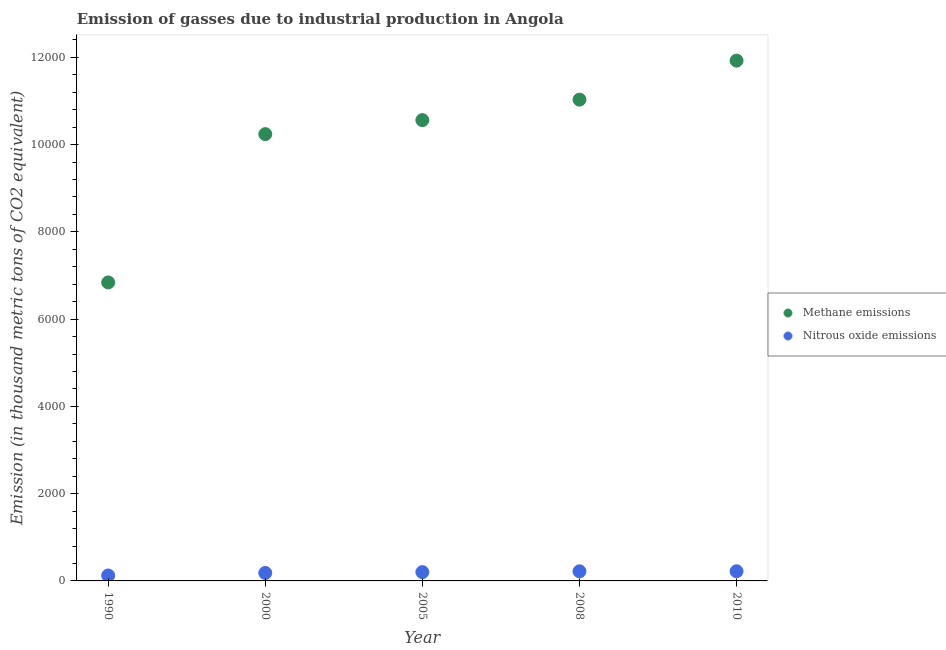How many different coloured dotlines are there?
Provide a succinct answer. 2. What is the amount of methane emissions in 1990?
Provide a succinct answer. 6841.7. Across all years, what is the maximum amount of methane emissions?
Offer a very short reply. 1.19e+04. Across all years, what is the minimum amount of nitrous oxide emissions?
Ensure brevity in your answer.  124.8. What is the total amount of methane emissions in the graph?
Provide a short and direct response. 5.06e+04. What is the difference between the amount of methane emissions in 1990 and that in 2008?
Your response must be concise. -4190.2. What is the difference between the amount of methane emissions in 2000 and the amount of nitrous oxide emissions in 2005?
Give a very brief answer. 1.00e+04. What is the average amount of methane emissions per year?
Provide a succinct answer. 1.01e+04. In the year 2010, what is the difference between the amount of methane emissions and amount of nitrous oxide emissions?
Your answer should be very brief. 1.17e+04. What is the ratio of the amount of nitrous oxide emissions in 2005 to that in 2010?
Make the answer very short. 0.91. What is the difference between the highest and the lowest amount of nitrous oxide emissions?
Provide a succinct answer. 96.6. In how many years, is the amount of nitrous oxide emissions greater than the average amount of nitrous oxide emissions taken over all years?
Your answer should be very brief. 3. Does the amount of nitrous oxide emissions monotonically increase over the years?
Give a very brief answer. Yes. Is the amount of nitrous oxide emissions strictly greater than the amount of methane emissions over the years?
Give a very brief answer. No. Is the amount of methane emissions strictly less than the amount of nitrous oxide emissions over the years?
Provide a short and direct response. No. How many dotlines are there?
Offer a very short reply. 2. How many years are there in the graph?
Your answer should be compact. 5. What is the difference between two consecutive major ticks on the Y-axis?
Your answer should be compact. 2000. Where does the legend appear in the graph?
Give a very brief answer. Center right. How are the legend labels stacked?
Your response must be concise. Vertical. What is the title of the graph?
Your answer should be compact. Emission of gasses due to industrial production in Angola. Does "Fertility rate" appear as one of the legend labels in the graph?
Offer a terse response. No. What is the label or title of the X-axis?
Keep it short and to the point. Year. What is the label or title of the Y-axis?
Ensure brevity in your answer.  Emission (in thousand metric tons of CO2 equivalent). What is the Emission (in thousand metric tons of CO2 equivalent) of Methane emissions in 1990?
Your answer should be compact. 6841.7. What is the Emission (in thousand metric tons of CO2 equivalent) in Nitrous oxide emissions in 1990?
Give a very brief answer. 124.8. What is the Emission (in thousand metric tons of CO2 equivalent) of Methane emissions in 2000?
Offer a very short reply. 1.02e+04. What is the Emission (in thousand metric tons of CO2 equivalent) in Nitrous oxide emissions in 2000?
Provide a succinct answer. 182.5. What is the Emission (in thousand metric tons of CO2 equivalent) in Methane emissions in 2005?
Offer a very short reply. 1.06e+04. What is the Emission (in thousand metric tons of CO2 equivalent) in Nitrous oxide emissions in 2005?
Your answer should be compact. 201.8. What is the Emission (in thousand metric tons of CO2 equivalent) of Methane emissions in 2008?
Provide a succinct answer. 1.10e+04. What is the Emission (in thousand metric tons of CO2 equivalent) of Nitrous oxide emissions in 2008?
Offer a terse response. 220.4. What is the Emission (in thousand metric tons of CO2 equivalent) of Methane emissions in 2010?
Provide a succinct answer. 1.19e+04. What is the Emission (in thousand metric tons of CO2 equivalent) of Nitrous oxide emissions in 2010?
Make the answer very short. 221.4. Across all years, what is the maximum Emission (in thousand metric tons of CO2 equivalent) of Methane emissions?
Provide a short and direct response. 1.19e+04. Across all years, what is the maximum Emission (in thousand metric tons of CO2 equivalent) of Nitrous oxide emissions?
Offer a very short reply. 221.4. Across all years, what is the minimum Emission (in thousand metric tons of CO2 equivalent) of Methane emissions?
Offer a very short reply. 6841.7. Across all years, what is the minimum Emission (in thousand metric tons of CO2 equivalent) in Nitrous oxide emissions?
Make the answer very short. 124.8. What is the total Emission (in thousand metric tons of CO2 equivalent) in Methane emissions in the graph?
Offer a very short reply. 5.06e+04. What is the total Emission (in thousand metric tons of CO2 equivalent) in Nitrous oxide emissions in the graph?
Give a very brief answer. 950.9. What is the difference between the Emission (in thousand metric tons of CO2 equivalent) in Methane emissions in 1990 and that in 2000?
Provide a short and direct response. -3399.1. What is the difference between the Emission (in thousand metric tons of CO2 equivalent) of Nitrous oxide emissions in 1990 and that in 2000?
Your answer should be compact. -57.7. What is the difference between the Emission (in thousand metric tons of CO2 equivalent) in Methane emissions in 1990 and that in 2005?
Make the answer very short. -3720.7. What is the difference between the Emission (in thousand metric tons of CO2 equivalent) in Nitrous oxide emissions in 1990 and that in 2005?
Provide a short and direct response. -77. What is the difference between the Emission (in thousand metric tons of CO2 equivalent) in Methane emissions in 1990 and that in 2008?
Give a very brief answer. -4190.2. What is the difference between the Emission (in thousand metric tons of CO2 equivalent) of Nitrous oxide emissions in 1990 and that in 2008?
Make the answer very short. -95.6. What is the difference between the Emission (in thousand metric tons of CO2 equivalent) of Methane emissions in 1990 and that in 2010?
Offer a terse response. -5084.3. What is the difference between the Emission (in thousand metric tons of CO2 equivalent) in Nitrous oxide emissions in 1990 and that in 2010?
Provide a succinct answer. -96.6. What is the difference between the Emission (in thousand metric tons of CO2 equivalent) of Methane emissions in 2000 and that in 2005?
Ensure brevity in your answer.  -321.6. What is the difference between the Emission (in thousand metric tons of CO2 equivalent) in Nitrous oxide emissions in 2000 and that in 2005?
Ensure brevity in your answer.  -19.3. What is the difference between the Emission (in thousand metric tons of CO2 equivalent) in Methane emissions in 2000 and that in 2008?
Your answer should be compact. -791.1. What is the difference between the Emission (in thousand metric tons of CO2 equivalent) of Nitrous oxide emissions in 2000 and that in 2008?
Offer a very short reply. -37.9. What is the difference between the Emission (in thousand metric tons of CO2 equivalent) in Methane emissions in 2000 and that in 2010?
Ensure brevity in your answer.  -1685.2. What is the difference between the Emission (in thousand metric tons of CO2 equivalent) in Nitrous oxide emissions in 2000 and that in 2010?
Your answer should be very brief. -38.9. What is the difference between the Emission (in thousand metric tons of CO2 equivalent) of Methane emissions in 2005 and that in 2008?
Ensure brevity in your answer.  -469.5. What is the difference between the Emission (in thousand metric tons of CO2 equivalent) of Nitrous oxide emissions in 2005 and that in 2008?
Ensure brevity in your answer.  -18.6. What is the difference between the Emission (in thousand metric tons of CO2 equivalent) in Methane emissions in 2005 and that in 2010?
Ensure brevity in your answer.  -1363.6. What is the difference between the Emission (in thousand metric tons of CO2 equivalent) in Nitrous oxide emissions in 2005 and that in 2010?
Make the answer very short. -19.6. What is the difference between the Emission (in thousand metric tons of CO2 equivalent) in Methane emissions in 2008 and that in 2010?
Your answer should be very brief. -894.1. What is the difference between the Emission (in thousand metric tons of CO2 equivalent) of Nitrous oxide emissions in 2008 and that in 2010?
Give a very brief answer. -1. What is the difference between the Emission (in thousand metric tons of CO2 equivalent) of Methane emissions in 1990 and the Emission (in thousand metric tons of CO2 equivalent) of Nitrous oxide emissions in 2000?
Offer a very short reply. 6659.2. What is the difference between the Emission (in thousand metric tons of CO2 equivalent) of Methane emissions in 1990 and the Emission (in thousand metric tons of CO2 equivalent) of Nitrous oxide emissions in 2005?
Your response must be concise. 6639.9. What is the difference between the Emission (in thousand metric tons of CO2 equivalent) of Methane emissions in 1990 and the Emission (in thousand metric tons of CO2 equivalent) of Nitrous oxide emissions in 2008?
Your answer should be compact. 6621.3. What is the difference between the Emission (in thousand metric tons of CO2 equivalent) in Methane emissions in 1990 and the Emission (in thousand metric tons of CO2 equivalent) in Nitrous oxide emissions in 2010?
Offer a terse response. 6620.3. What is the difference between the Emission (in thousand metric tons of CO2 equivalent) of Methane emissions in 2000 and the Emission (in thousand metric tons of CO2 equivalent) of Nitrous oxide emissions in 2005?
Offer a terse response. 1.00e+04. What is the difference between the Emission (in thousand metric tons of CO2 equivalent) in Methane emissions in 2000 and the Emission (in thousand metric tons of CO2 equivalent) in Nitrous oxide emissions in 2008?
Ensure brevity in your answer.  1.00e+04. What is the difference between the Emission (in thousand metric tons of CO2 equivalent) of Methane emissions in 2000 and the Emission (in thousand metric tons of CO2 equivalent) of Nitrous oxide emissions in 2010?
Offer a terse response. 1.00e+04. What is the difference between the Emission (in thousand metric tons of CO2 equivalent) of Methane emissions in 2005 and the Emission (in thousand metric tons of CO2 equivalent) of Nitrous oxide emissions in 2008?
Your answer should be very brief. 1.03e+04. What is the difference between the Emission (in thousand metric tons of CO2 equivalent) in Methane emissions in 2005 and the Emission (in thousand metric tons of CO2 equivalent) in Nitrous oxide emissions in 2010?
Make the answer very short. 1.03e+04. What is the difference between the Emission (in thousand metric tons of CO2 equivalent) of Methane emissions in 2008 and the Emission (in thousand metric tons of CO2 equivalent) of Nitrous oxide emissions in 2010?
Keep it short and to the point. 1.08e+04. What is the average Emission (in thousand metric tons of CO2 equivalent) in Methane emissions per year?
Offer a terse response. 1.01e+04. What is the average Emission (in thousand metric tons of CO2 equivalent) in Nitrous oxide emissions per year?
Provide a short and direct response. 190.18. In the year 1990, what is the difference between the Emission (in thousand metric tons of CO2 equivalent) of Methane emissions and Emission (in thousand metric tons of CO2 equivalent) of Nitrous oxide emissions?
Keep it short and to the point. 6716.9. In the year 2000, what is the difference between the Emission (in thousand metric tons of CO2 equivalent) of Methane emissions and Emission (in thousand metric tons of CO2 equivalent) of Nitrous oxide emissions?
Ensure brevity in your answer.  1.01e+04. In the year 2005, what is the difference between the Emission (in thousand metric tons of CO2 equivalent) in Methane emissions and Emission (in thousand metric tons of CO2 equivalent) in Nitrous oxide emissions?
Your answer should be very brief. 1.04e+04. In the year 2008, what is the difference between the Emission (in thousand metric tons of CO2 equivalent) in Methane emissions and Emission (in thousand metric tons of CO2 equivalent) in Nitrous oxide emissions?
Offer a very short reply. 1.08e+04. In the year 2010, what is the difference between the Emission (in thousand metric tons of CO2 equivalent) in Methane emissions and Emission (in thousand metric tons of CO2 equivalent) in Nitrous oxide emissions?
Your response must be concise. 1.17e+04. What is the ratio of the Emission (in thousand metric tons of CO2 equivalent) of Methane emissions in 1990 to that in 2000?
Offer a terse response. 0.67. What is the ratio of the Emission (in thousand metric tons of CO2 equivalent) of Nitrous oxide emissions in 1990 to that in 2000?
Make the answer very short. 0.68. What is the ratio of the Emission (in thousand metric tons of CO2 equivalent) in Methane emissions in 1990 to that in 2005?
Your answer should be compact. 0.65. What is the ratio of the Emission (in thousand metric tons of CO2 equivalent) in Nitrous oxide emissions in 1990 to that in 2005?
Your answer should be very brief. 0.62. What is the ratio of the Emission (in thousand metric tons of CO2 equivalent) of Methane emissions in 1990 to that in 2008?
Ensure brevity in your answer.  0.62. What is the ratio of the Emission (in thousand metric tons of CO2 equivalent) in Nitrous oxide emissions in 1990 to that in 2008?
Offer a terse response. 0.57. What is the ratio of the Emission (in thousand metric tons of CO2 equivalent) in Methane emissions in 1990 to that in 2010?
Provide a short and direct response. 0.57. What is the ratio of the Emission (in thousand metric tons of CO2 equivalent) in Nitrous oxide emissions in 1990 to that in 2010?
Your response must be concise. 0.56. What is the ratio of the Emission (in thousand metric tons of CO2 equivalent) of Methane emissions in 2000 to that in 2005?
Provide a succinct answer. 0.97. What is the ratio of the Emission (in thousand metric tons of CO2 equivalent) in Nitrous oxide emissions in 2000 to that in 2005?
Offer a very short reply. 0.9. What is the ratio of the Emission (in thousand metric tons of CO2 equivalent) in Methane emissions in 2000 to that in 2008?
Provide a succinct answer. 0.93. What is the ratio of the Emission (in thousand metric tons of CO2 equivalent) of Nitrous oxide emissions in 2000 to that in 2008?
Make the answer very short. 0.83. What is the ratio of the Emission (in thousand metric tons of CO2 equivalent) in Methane emissions in 2000 to that in 2010?
Provide a succinct answer. 0.86. What is the ratio of the Emission (in thousand metric tons of CO2 equivalent) in Nitrous oxide emissions in 2000 to that in 2010?
Provide a succinct answer. 0.82. What is the ratio of the Emission (in thousand metric tons of CO2 equivalent) of Methane emissions in 2005 to that in 2008?
Ensure brevity in your answer.  0.96. What is the ratio of the Emission (in thousand metric tons of CO2 equivalent) of Nitrous oxide emissions in 2005 to that in 2008?
Your answer should be compact. 0.92. What is the ratio of the Emission (in thousand metric tons of CO2 equivalent) in Methane emissions in 2005 to that in 2010?
Offer a very short reply. 0.89. What is the ratio of the Emission (in thousand metric tons of CO2 equivalent) of Nitrous oxide emissions in 2005 to that in 2010?
Offer a terse response. 0.91. What is the ratio of the Emission (in thousand metric tons of CO2 equivalent) in Methane emissions in 2008 to that in 2010?
Ensure brevity in your answer.  0.93. What is the ratio of the Emission (in thousand metric tons of CO2 equivalent) of Nitrous oxide emissions in 2008 to that in 2010?
Offer a very short reply. 1. What is the difference between the highest and the second highest Emission (in thousand metric tons of CO2 equivalent) in Methane emissions?
Offer a terse response. 894.1. What is the difference between the highest and the second highest Emission (in thousand metric tons of CO2 equivalent) of Nitrous oxide emissions?
Give a very brief answer. 1. What is the difference between the highest and the lowest Emission (in thousand metric tons of CO2 equivalent) in Methane emissions?
Your response must be concise. 5084.3. What is the difference between the highest and the lowest Emission (in thousand metric tons of CO2 equivalent) of Nitrous oxide emissions?
Your answer should be very brief. 96.6. 